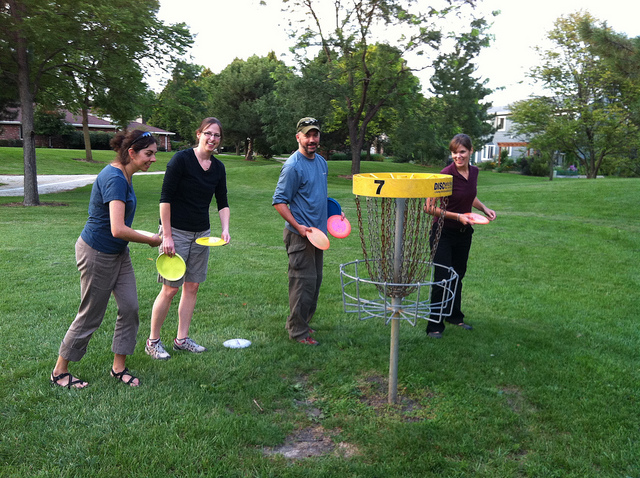Read all the text in this image. 7 